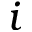Convert formula to latex. <formula><loc_0><loc_0><loc_500><loc_500>i</formula> 